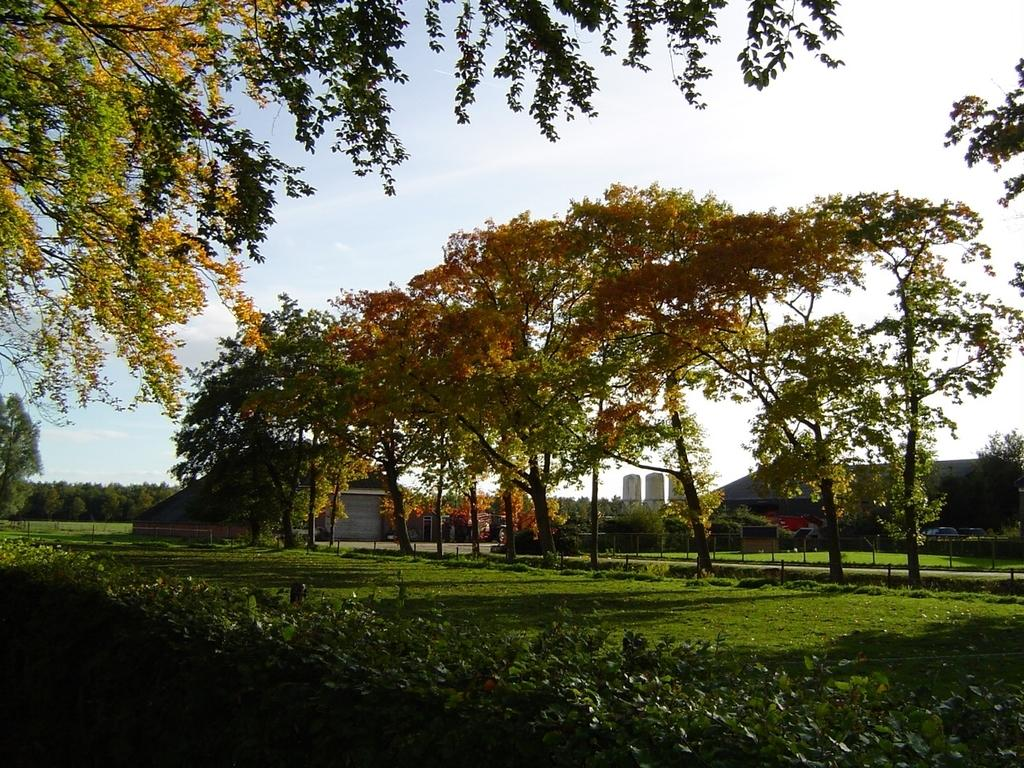What type of vegetation can be seen in the image? There are trees in the image. What is present at the bottom of the image? There is grass and plants at the bottom of the image. What is visible at the top of the image? The sky is visible at the top of the image. Can you see any blood stains on the jeans in the image? There are no jeans or blood stains present in the image. What is located in the middle of the image? The image does not have a specific "middle" as it is a photograph, not a physical object. 